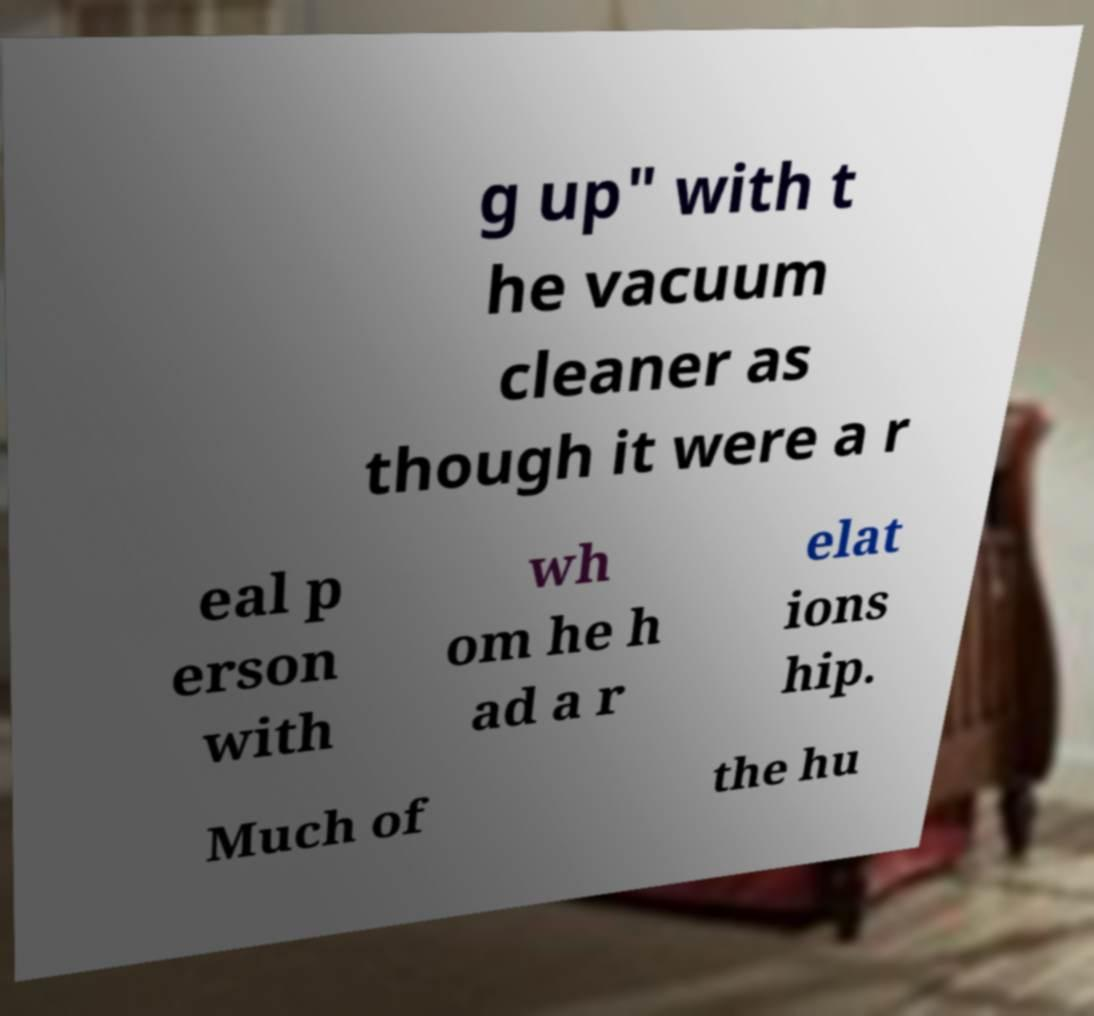Please identify and transcribe the text found in this image. g up" with t he vacuum cleaner as though it were a r eal p erson with wh om he h ad a r elat ions hip. Much of the hu 